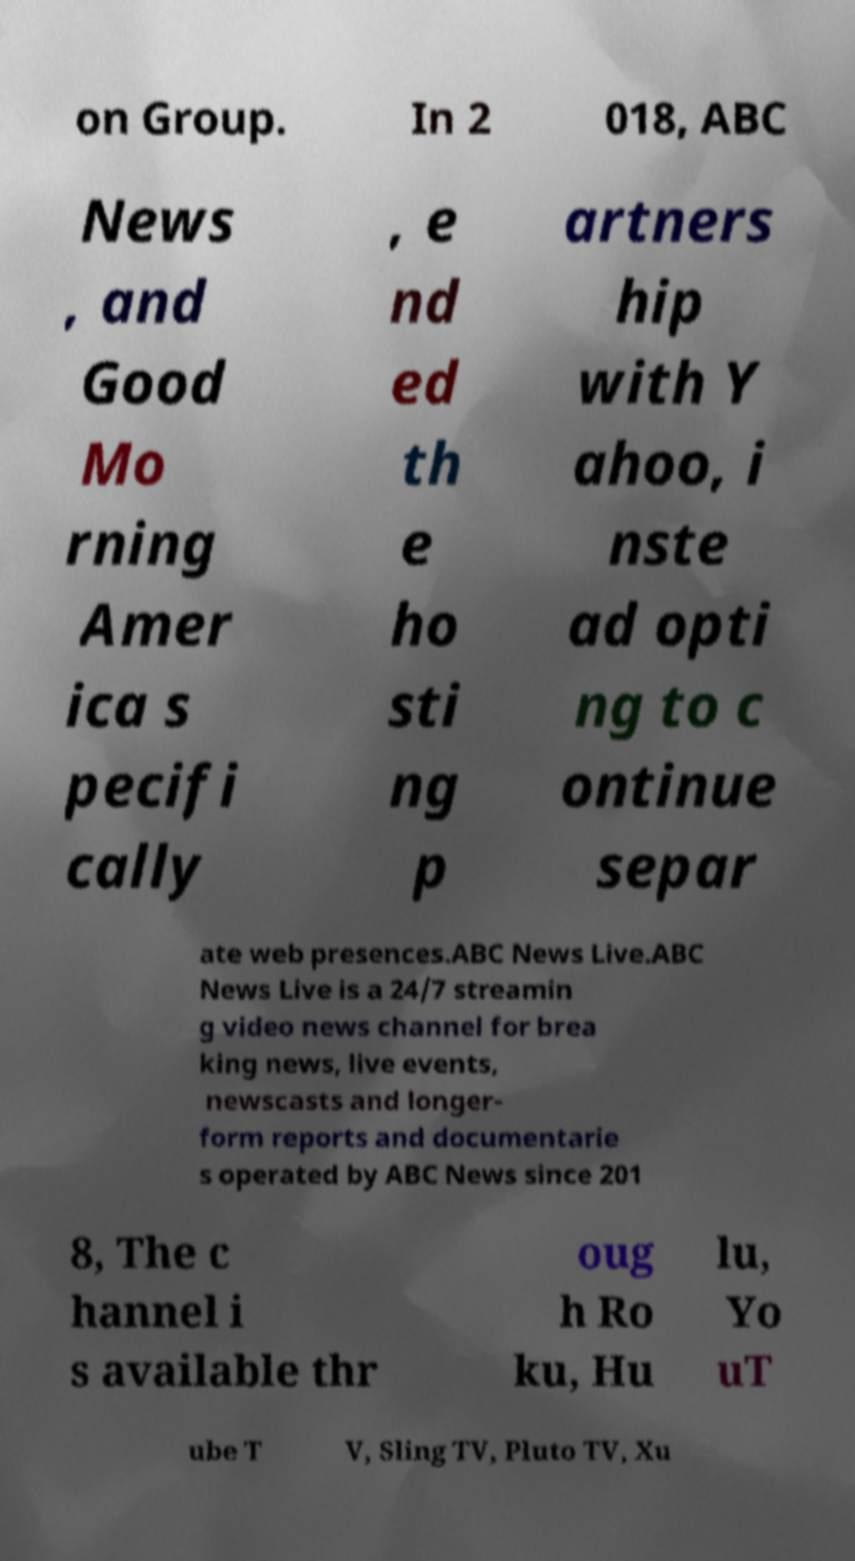Could you assist in decoding the text presented in this image and type it out clearly? on Group. In 2 018, ABC News , and Good Mo rning Amer ica s pecifi cally , e nd ed th e ho sti ng p artners hip with Y ahoo, i nste ad opti ng to c ontinue separ ate web presences.ABC News Live.ABC News Live is a 24/7 streamin g video news channel for brea king news, live events, newscasts and longer- form reports and documentarie s operated by ABC News since 201 8, The c hannel i s available thr oug h Ro ku, Hu lu, Yo uT ube T V, Sling TV, Pluto TV, Xu 